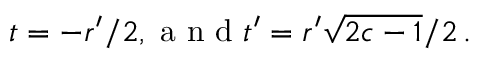Convert formula to latex. <formula><loc_0><loc_0><loc_500><loc_500>t = - r ^ { \prime } / 2 , a n d t ^ { \prime } = r ^ { \prime } \sqrt { 2 c - 1 } / 2 \, .</formula> 